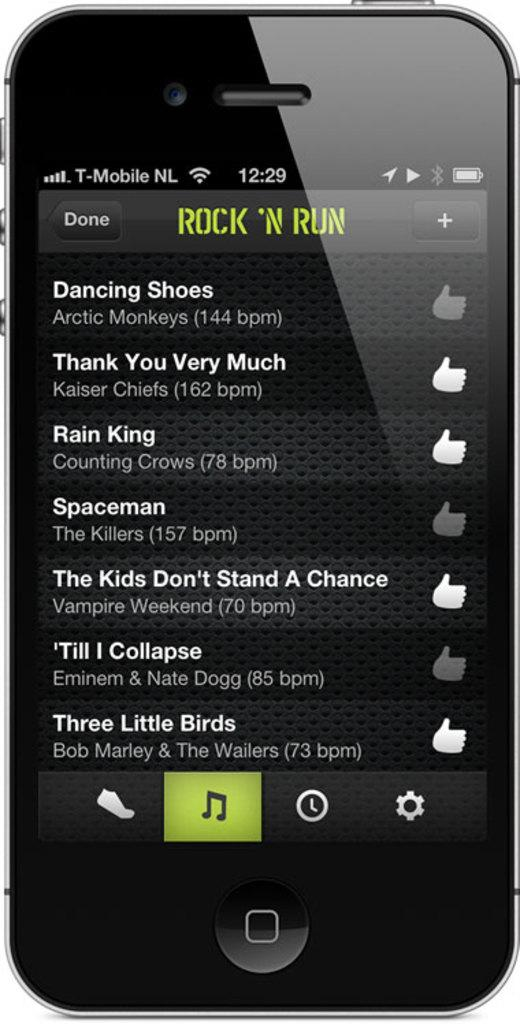<image>
Relay a brief, clear account of the picture shown. A smartphone screen that shows a Rock 'n Run music playlist. 